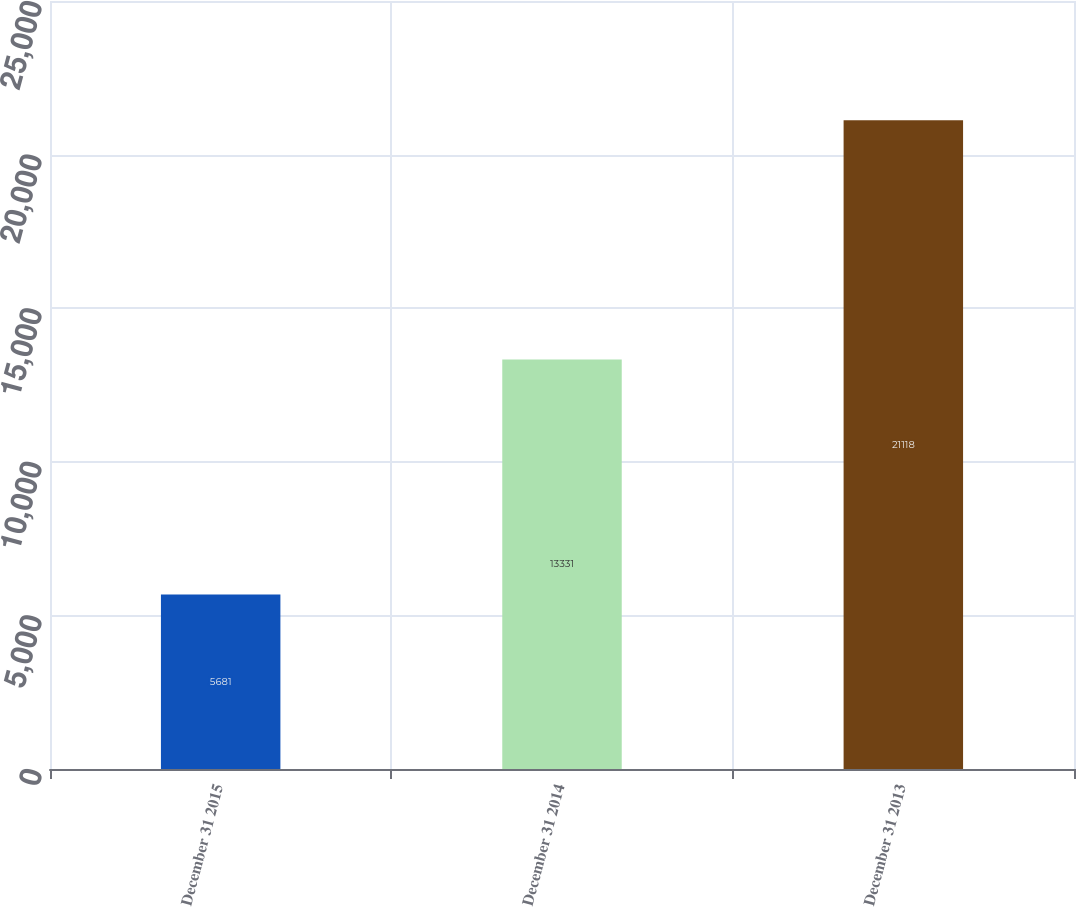<chart> <loc_0><loc_0><loc_500><loc_500><bar_chart><fcel>December 31 2015<fcel>December 31 2014<fcel>December 31 2013<nl><fcel>5681<fcel>13331<fcel>21118<nl></chart> 